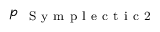Convert formula to latex. <formula><loc_0><loc_0><loc_500><loc_500>p _ { { S y m p l e c t i c 2 } }</formula> 